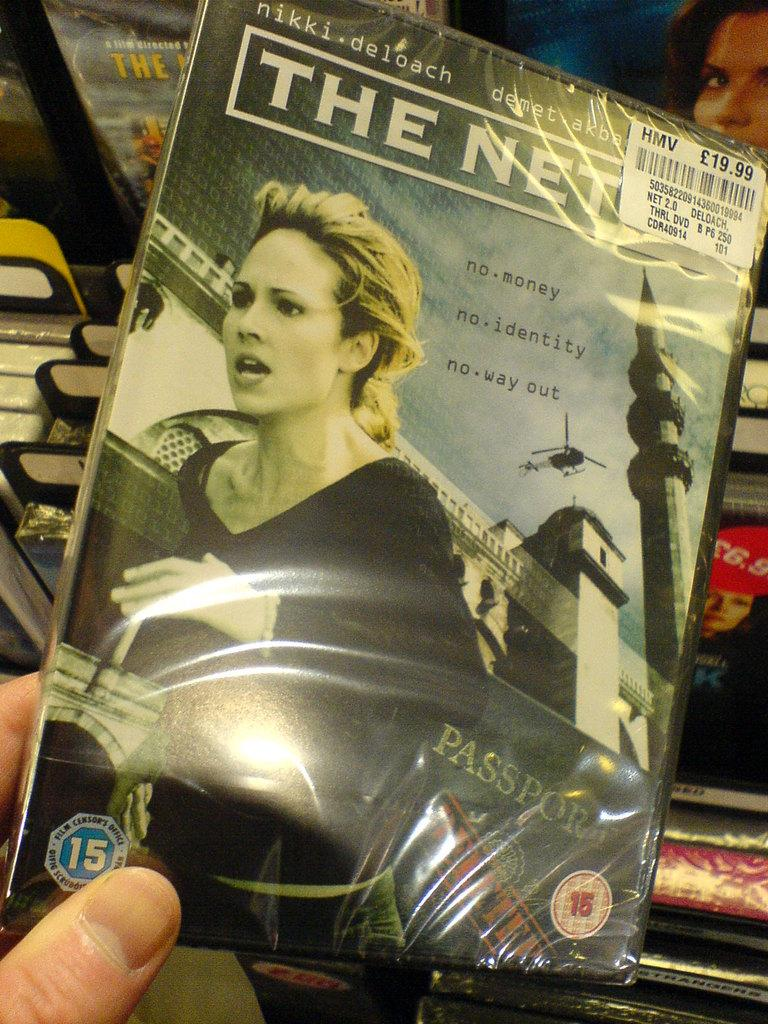<image>
Render a clear and concise summary of the photo. A person holding a DVD case, the title is covered, but it begins with "The Net". 